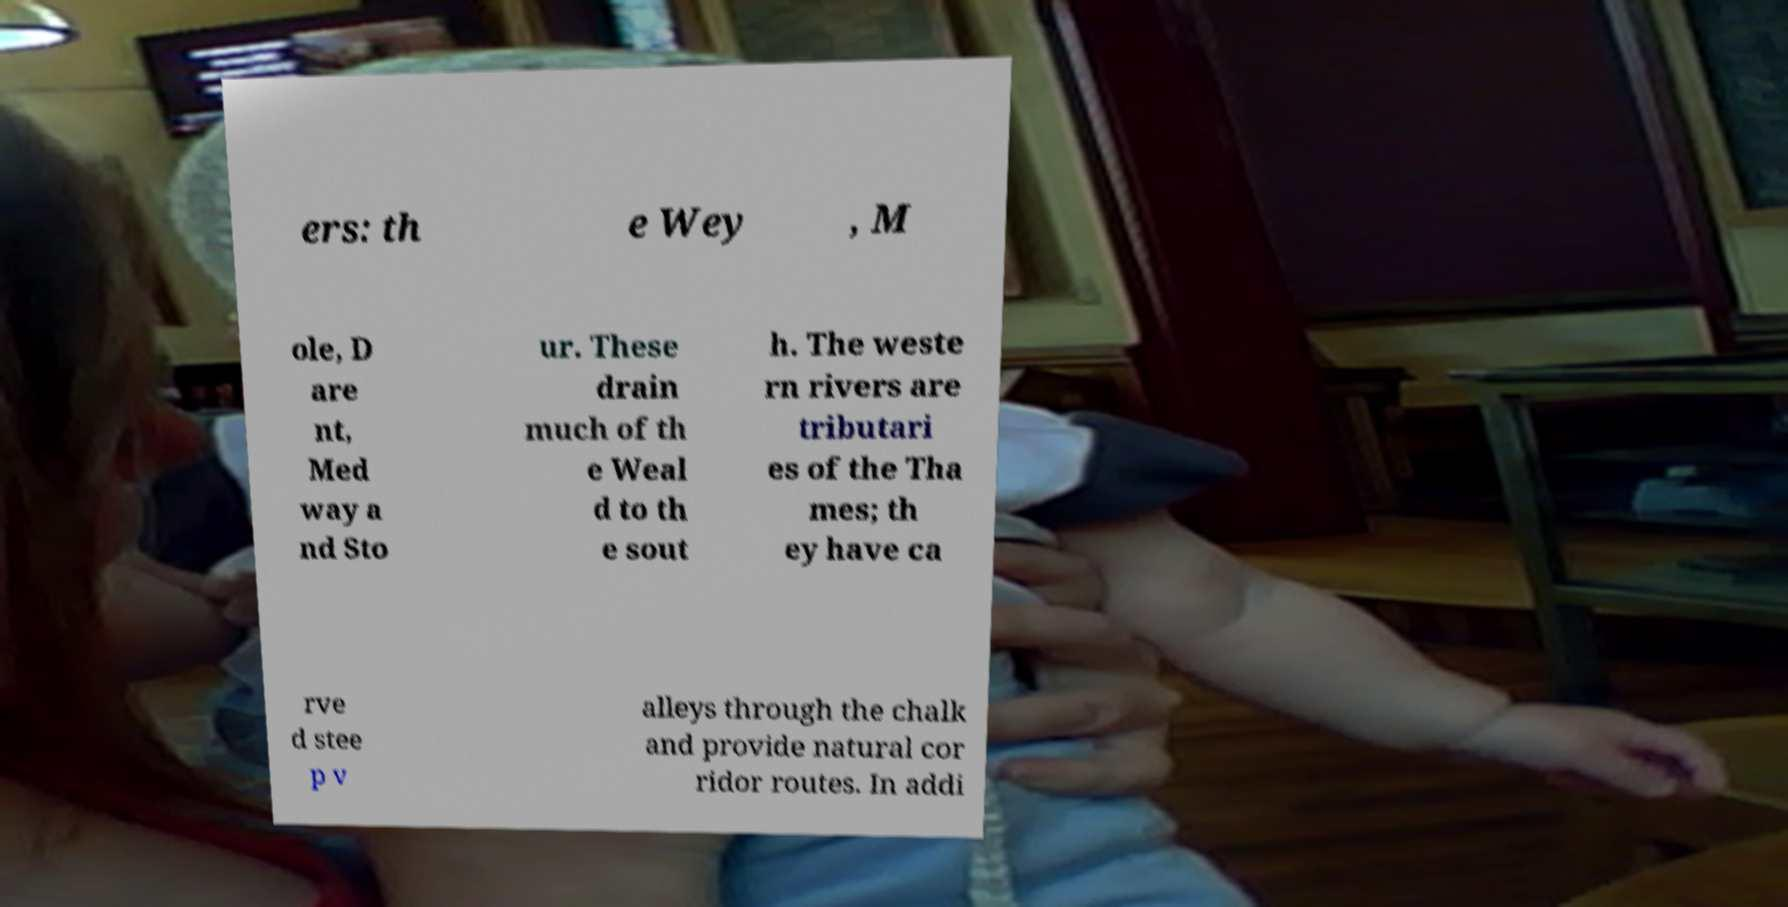Can you read and provide the text displayed in the image?This photo seems to have some interesting text. Can you extract and type it out for me? ers: th e Wey , M ole, D are nt, Med way a nd Sto ur. These drain much of th e Weal d to th e sout h. The weste rn rivers are tributari es of the Tha mes; th ey have ca rve d stee p v alleys through the chalk and provide natural cor ridor routes. In addi 